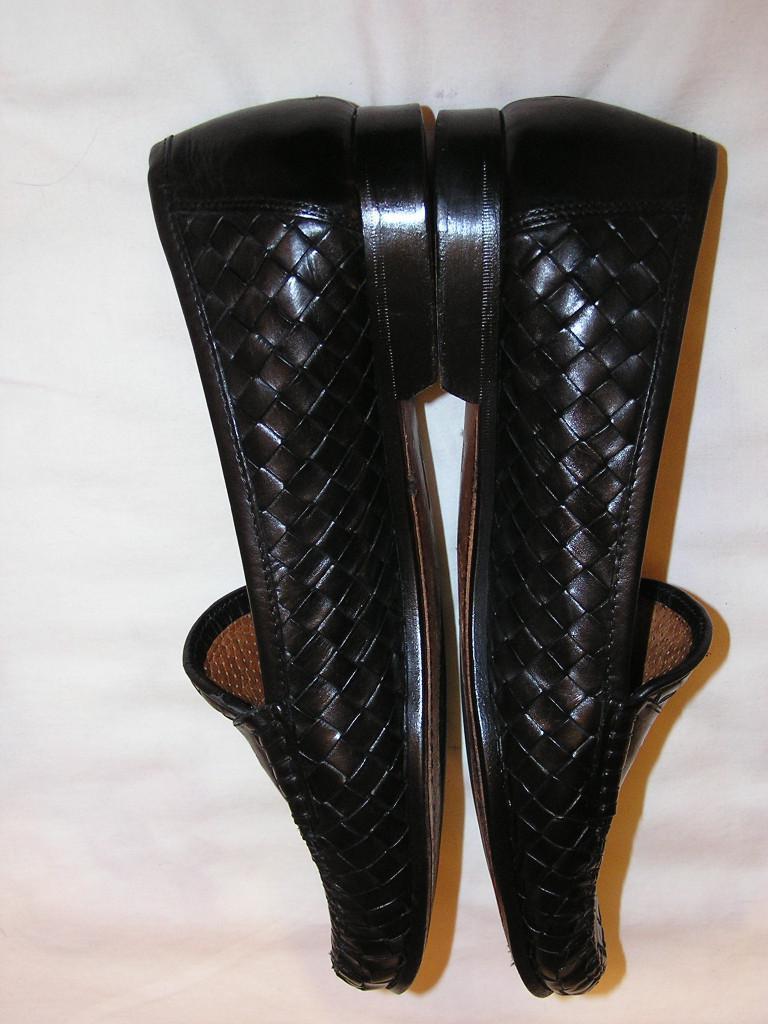Please provide a concise description of this image. In this picture there are shoes in the center of the image. 